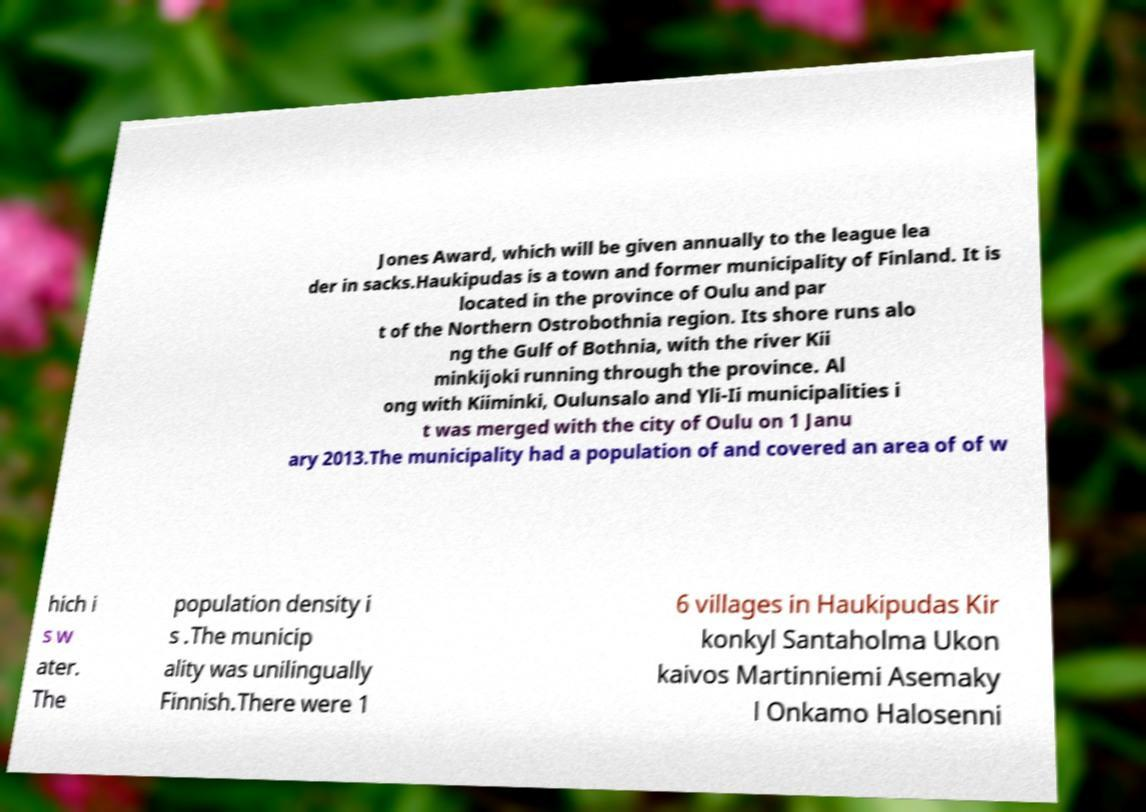Can you read and provide the text displayed in the image?This photo seems to have some interesting text. Can you extract and type it out for me? Jones Award, which will be given annually to the league lea der in sacks.Haukipudas is a town and former municipality of Finland. It is located in the province of Oulu and par t of the Northern Ostrobothnia region. Its shore runs alo ng the Gulf of Bothnia, with the river Kii minkijoki running through the province. Al ong with Kiiminki, Oulunsalo and Yli-Ii municipalities i t was merged with the city of Oulu on 1 Janu ary 2013.The municipality had a population of and covered an area of of w hich i s w ater. The population density i s .The municip ality was unilingually Finnish.There were 1 6 villages in Haukipudas Kir konkyl Santaholma Ukon kaivos Martinniemi Asemaky l Onkamo Halosenni 